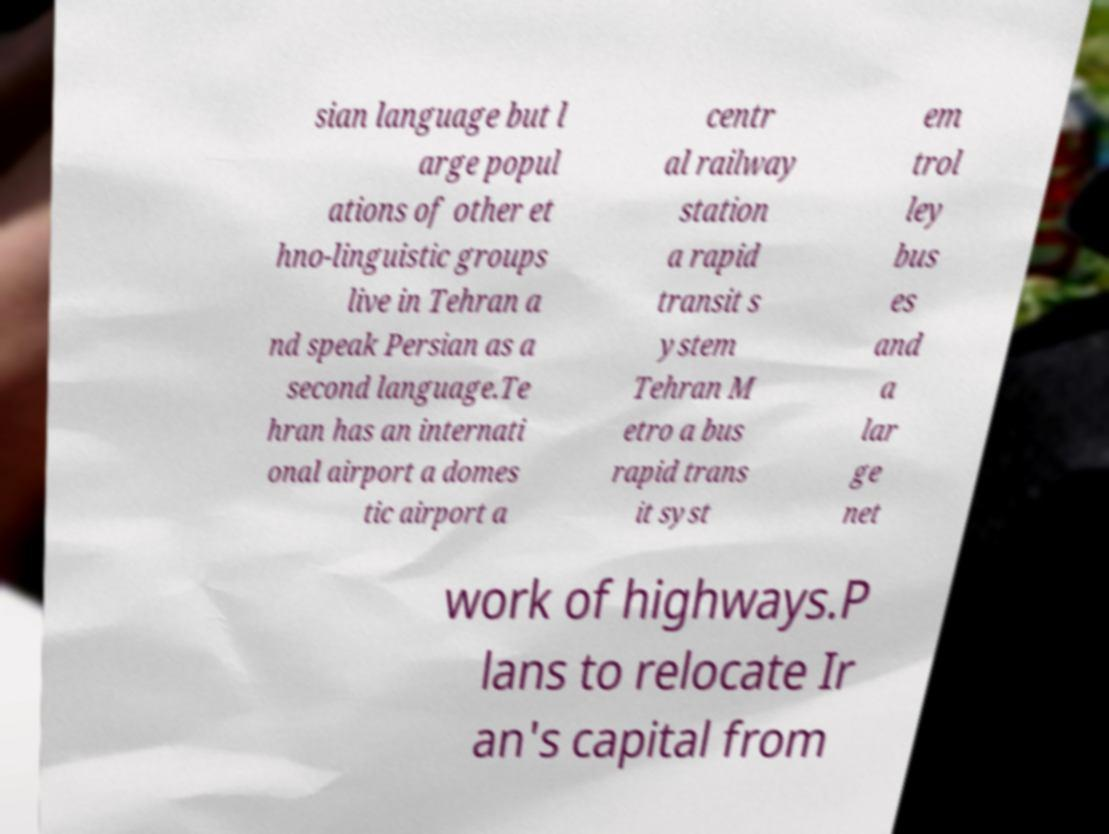Can you read and provide the text displayed in the image?This photo seems to have some interesting text. Can you extract and type it out for me? sian language but l arge popul ations of other et hno-linguistic groups live in Tehran a nd speak Persian as a second language.Te hran has an internati onal airport a domes tic airport a centr al railway station a rapid transit s ystem Tehran M etro a bus rapid trans it syst em trol ley bus es and a lar ge net work of highways.P lans to relocate Ir an's capital from 